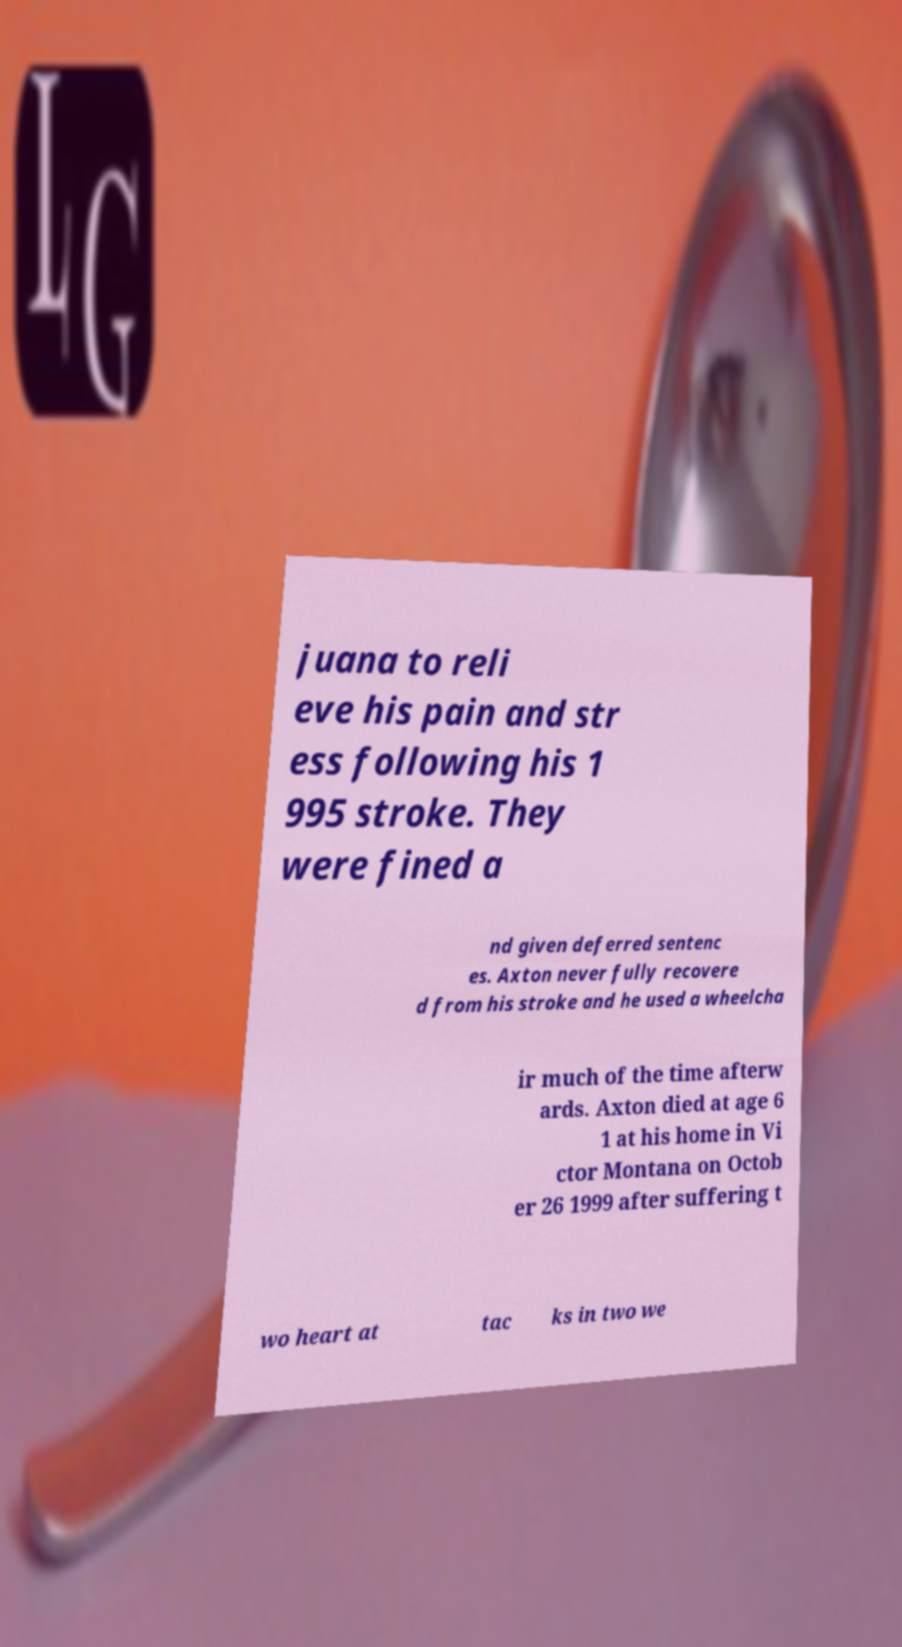Could you assist in decoding the text presented in this image and type it out clearly? juana to reli eve his pain and str ess following his 1 995 stroke. They were fined a nd given deferred sentenc es. Axton never fully recovere d from his stroke and he used a wheelcha ir much of the time afterw ards. Axton died at age 6 1 at his home in Vi ctor Montana on Octob er 26 1999 after suffering t wo heart at tac ks in two we 